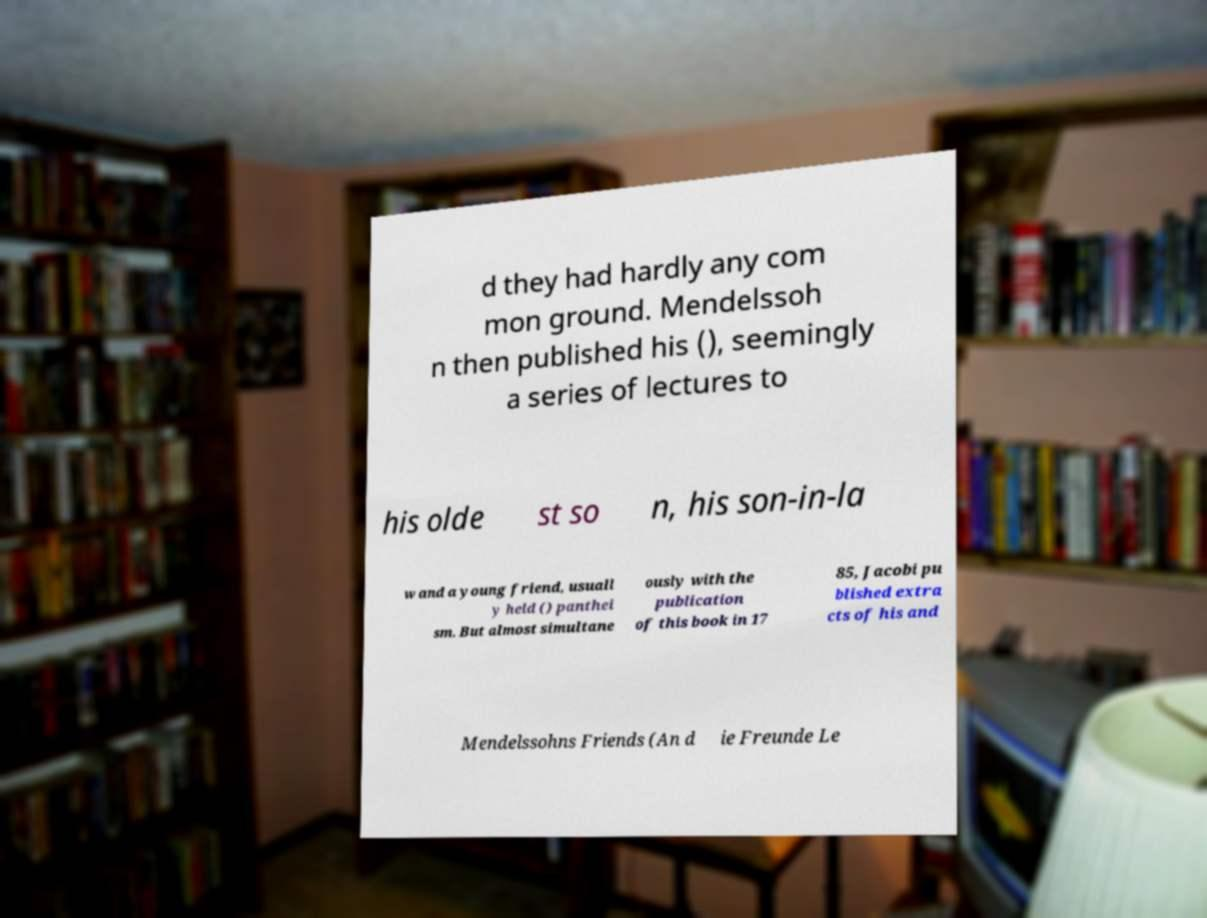Can you accurately transcribe the text from the provided image for me? d they had hardly any com mon ground. Mendelssoh n then published his (), seemingly a series of lectures to his olde st so n, his son-in-la w and a young friend, usuall y held () panthei sm. But almost simultane ously with the publication of this book in 17 85, Jacobi pu blished extra cts of his and Mendelssohns Friends (An d ie Freunde Le 